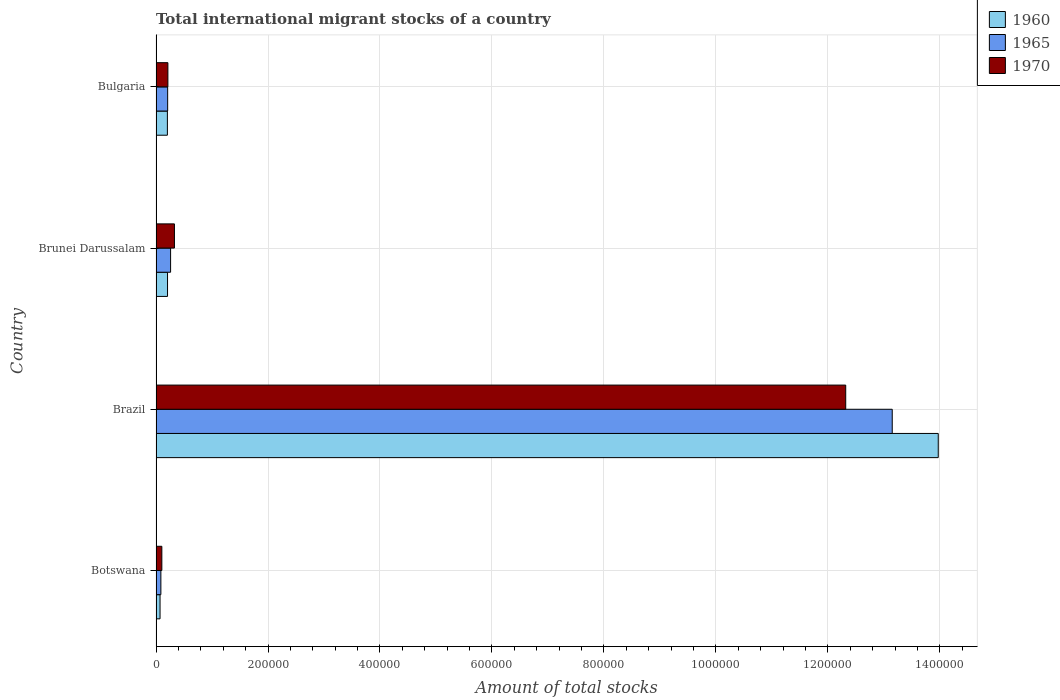How many different coloured bars are there?
Provide a short and direct response. 3. Are the number of bars on each tick of the Y-axis equal?
Provide a succinct answer. Yes. How many bars are there on the 1st tick from the top?
Ensure brevity in your answer.  3. How many bars are there on the 4th tick from the bottom?
Your answer should be very brief. 3. In how many cases, is the number of bars for a given country not equal to the number of legend labels?
Your response must be concise. 0. What is the amount of total stocks in in 1960 in Brazil?
Your response must be concise. 1.40e+06. Across all countries, what is the maximum amount of total stocks in in 1960?
Make the answer very short. 1.40e+06. Across all countries, what is the minimum amount of total stocks in in 1960?
Provide a short and direct response. 7199. In which country was the amount of total stocks in in 1965 minimum?
Your answer should be compact. Botswana. What is the total amount of total stocks in in 1965 in the graph?
Provide a succinct answer. 1.37e+06. What is the difference between the amount of total stocks in in 1965 in Brazil and that in Brunei Darussalam?
Provide a succinct answer. 1.29e+06. What is the difference between the amount of total stocks in in 1960 in Brunei Darussalam and the amount of total stocks in in 1970 in Botswana?
Your answer should be compact. 1.02e+04. What is the average amount of total stocks in in 1970 per country?
Provide a short and direct response. 3.24e+05. What is the difference between the amount of total stocks in in 1970 and amount of total stocks in in 1960 in Brazil?
Offer a very short reply. -1.65e+05. In how many countries, is the amount of total stocks in in 1970 greater than 200000 ?
Offer a very short reply. 1. What is the ratio of the amount of total stocks in in 1970 in Botswana to that in Brazil?
Provide a succinct answer. 0.01. Is the amount of total stocks in in 1960 in Botswana less than that in Brunei Darussalam?
Provide a succinct answer. Yes. What is the difference between the highest and the second highest amount of total stocks in in 1970?
Make the answer very short. 1.20e+06. What is the difference between the highest and the lowest amount of total stocks in in 1970?
Provide a succinct answer. 1.22e+06. In how many countries, is the amount of total stocks in in 1965 greater than the average amount of total stocks in in 1965 taken over all countries?
Provide a succinct answer. 1. How many bars are there?
Give a very brief answer. 12. How many countries are there in the graph?
Provide a succinct answer. 4. What is the difference between two consecutive major ticks on the X-axis?
Ensure brevity in your answer.  2.00e+05. Where does the legend appear in the graph?
Provide a short and direct response. Top right. How many legend labels are there?
Your response must be concise. 3. What is the title of the graph?
Keep it short and to the point. Total international migrant stocks of a country. What is the label or title of the X-axis?
Your answer should be very brief. Amount of total stocks. What is the label or title of the Y-axis?
Provide a short and direct response. Country. What is the Amount of total stocks in 1960 in Botswana?
Offer a very short reply. 7199. What is the Amount of total stocks of 1965 in Botswana?
Provide a succinct answer. 8655. What is the Amount of total stocks of 1970 in Botswana?
Provide a short and direct response. 1.04e+04. What is the Amount of total stocks of 1960 in Brazil?
Give a very brief answer. 1.40e+06. What is the Amount of total stocks of 1965 in Brazil?
Offer a very short reply. 1.31e+06. What is the Amount of total stocks of 1970 in Brazil?
Make the answer very short. 1.23e+06. What is the Amount of total stocks in 1960 in Brunei Darussalam?
Offer a terse response. 2.06e+04. What is the Amount of total stocks in 1965 in Brunei Darussalam?
Give a very brief answer. 2.60e+04. What is the Amount of total stocks of 1970 in Brunei Darussalam?
Provide a succinct answer. 3.29e+04. What is the Amount of total stocks of 1960 in Bulgaria?
Provide a succinct answer. 2.03e+04. What is the Amount of total stocks of 1965 in Bulgaria?
Provide a succinct answer. 2.08e+04. What is the Amount of total stocks of 1970 in Bulgaria?
Provide a succinct answer. 2.12e+04. Across all countries, what is the maximum Amount of total stocks in 1960?
Make the answer very short. 1.40e+06. Across all countries, what is the maximum Amount of total stocks in 1965?
Make the answer very short. 1.31e+06. Across all countries, what is the maximum Amount of total stocks of 1970?
Make the answer very short. 1.23e+06. Across all countries, what is the minimum Amount of total stocks in 1960?
Make the answer very short. 7199. Across all countries, what is the minimum Amount of total stocks of 1965?
Your answer should be very brief. 8655. Across all countries, what is the minimum Amount of total stocks of 1970?
Your answer should be very brief. 1.04e+04. What is the total Amount of total stocks in 1960 in the graph?
Offer a terse response. 1.45e+06. What is the total Amount of total stocks in 1965 in the graph?
Keep it short and to the point. 1.37e+06. What is the total Amount of total stocks in 1970 in the graph?
Your response must be concise. 1.30e+06. What is the difference between the Amount of total stocks in 1960 in Botswana and that in Brazil?
Your answer should be compact. -1.39e+06. What is the difference between the Amount of total stocks in 1965 in Botswana and that in Brazil?
Keep it short and to the point. -1.31e+06. What is the difference between the Amount of total stocks of 1970 in Botswana and that in Brazil?
Offer a terse response. -1.22e+06. What is the difference between the Amount of total stocks in 1960 in Botswana and that in Brunei Darussalam?
Offer a terse response. -1.34e+04. What is the difference between the Amount of total stocks of 1965 in Botswana and that in Brunei Darussalam?
Your response must be concise. -1.74e+04. What is the difference between the Amount of total stocks in 1970 in Botswana and that in Brunei Darussalam?
Provide a short and direct response. -2.25e+04. What is the difference between the Amount of total stocks of 1960 in Botswana and that in Bulgaria?
Offer a terse response. -1.31e+04. What is the difference between the Amount of total stocks in 1965 in Botswana and that in Bulgaria?
Provide a short and direct response. -1.21e+04. What is the difference between the Amount of total stocks in 1970 in Botswana and that in Bulgaria?
Ensure brevity in your answer.  -1.08e+04. What is the difference between the Amount of total stocks of 1960 in Brazil and that in Brunei Darussalam?
Your response must be concise. 1.38e+06. What is the difference between the Amount of total stocks of 1965 in Brazil and that in Brunei Darussalam?
Provide a short and direct response. 1.29e+06. What is the difference between the Amount of total stocks of 1970 in Brazil and that in Brunei Darussalam?
Provide a short and direct response. 1.20e+06. What is the difference between the Amount of total stocks in 1960 in Brazil and that in Bulgaria?
Your response must be concise. 1.38e+06. What is the difference between the Amount of total stocks of 1965 in Brazil and that in Bulgaria?
Provide a succinct answer. 1.29e+06. What is the difference between the Amount of total stocks in 1970 in Brazil and that in Bulgaria?
Provide a short and direct response. 1.21e+06. What is the difference between the Amount of total stocks in 1960 in Brunei Darussalam and that in Bulgaria?
Keep it short and to the point. 267. What is the difference between the Amount of total stocks of 1965 in Brunei Darussalam and that in Bulgaria?
Keep it short and to the point. 5255. What is the difference between the Amount of total stocks of 1970 in Brunei Darussalam and that in Bulgaria?
Ensure brevity in your answer.  1.17e+04. What is the difference between the Amount of total stocks in 1960 in Botswana and the Amount of total stocks in 1965 in Brazil?
Your answer should be very brief. -1.31e+06. What is the difference between the Amount of total stocks of 1960 in Botswana and the Amount of total stocks of 1970 in Brazil?
Offer a very short reply. -1.22e+06. What is the difference between the Amount of total stocks of 1965 in Botswana and the Amount of total stocks of 1970 in Brazil?
Your response must be concise. -1.22e+06. What is the difference between the Amount of total stocks of 1960 in Botswana and the Amount of total stocks of 1965 in Brunei Darussalam?
Offer a very short reply. -1.88e+04. What is the difference between the Amount of total stocks of 1960 in Botswana and the Amount of total stocks of 1970 in Brunei Darussalam?
Your answer should be compact. -2.57e+04. What is the difference between the Amount of total stocks in 1965 in Botswana and the Amount of total stocks in 1970 in Brunei Darussalam?
Provide a succinct answer. -2.42e+04. What is the difference between the Amount of total stocks in 1960 in Botswana and the Amount of total stocks in 1965 in Bulgaria?
Your answer should be very brief. -1.36e+04. What is the difference between the Amount of total stocks of 1960 in Botswana and the Amount of total stocks of 1970 in Bulgaria?
Give a very brief answer. -1.40e+04. What is the difference between the Amount of total stocks of 1965 in Botswana and the Amount of total stocks of 1970 in Bulgaria?
Give a very brief answer. -1.25e+04. What is the difference between the Amount of total stocks of 1960 in Brazil and the Amount of total stocks of 1965 in Brunei Darussalam?
Provide a short and direct response. 1.37e+06. What is the difference between the Amount of total stocks in 1960 in Brazil and the Amount of total stocks in 1970 in Brunei Darussalam?
Provide a succinct answer. 1.36e+06. What is the difference between the Amount of total stocks in 1965 in Brazil and the Amount of total stocks in 1970 in Brunei Darussalam?
Give a very brief answer. 1.28e+06. What is the difference between the Amount of total stocks in 1960 in Brazil and the Amount of total stocks in 1965 in Bulgaria?
Offer a very short reply. 1.38e+06. What is the difference between the Amount of total stocks of 1960 in Brazil and the Amount of total stocks of 1970 in Bulgaria?
Your answer should be very brief. 1.38e+06. What is the difference between the Amount of total stocks of 1965 in Brazil and the Amount of total stocks of 1970 in Bulgaria?
Provide a short and direct response. 1.29e+06. What is the difference between the Amount of total stocks in 1960 in Brunei Darussalam and the Amount of total stocks in 1965 in Bulgaria?
Make the answer very short. -221. What is the difference between the Amount of total stocks of 1960 in Brunei Darussalam and the Amount of total stocks of 1970 in Bulgaria?
Ensure brevity in your answer.  -627. What is the difference between the Amount of total stocks of 1965 in Brunei Darussalam and the Amount of total stocks of 1970 in Bulgaria?
Offer a very short reply. 4849. What is the average Amount of total stocks in 1960 per country?
Ensure brevity in your answer.  3.61e+05. What is the average Amount of total stocks of 1965 per country?
Offer a very short reply. 3.43e+05. What is the average Amount of total stocks of 1970 per country?
Your response must be concise. 3.24e+05. What is the difference between the Amount of total stocks in 1960 and Amount of total stocks in 1965 in Botswana?
Your response must be concise. -1456. What is the difference between the Amount of total stocks of 1960 and Amount of total stocks of 1970 in Botswana?
Your answer should be very brief. -3205. What is the difference between the Amount of total stocks in 1965 and Amount of total stocks in 1970 in Botswana?
Give a very brief answer. -1749. What is the difference between the Amount of total stocks of 1960 and Amount of total stocks of 1965 in Brazil?
Provide a short and direct response. 8.22e+04. What is the difference between the Amount of total stocks of 1960 and Amount of total stocks of 1970 in Brazil?
Ensure brevity in your answer.  1.65e+05. What is the difference between the Amount of total stocks in 1965 and Amount of total stocks in 1970 in Brazil?
Provide a succinct answer. 8.31e+04. What is the difference between the Amount of total stocks of 1960 and Amount of total stocks of 1965 in Brunei Darussalam?
Ensure brevity in your answer.  -5476. What is the difference between the Amount of total stocks of 1960 and Amount of total stocks of 1970 in Brunei Darussalam?
Offer a very short reply. -1.23e+04. What is the difference between the Amount of total stocks in 1965 and Amount of total stocks in 1970 in Brunei Darussalam?
Keep it short and to the point. -6865. What is the difference between the Amount of total stocks in 1960 and Amount of total stocks in 1965 in Bulgaria?
Provide a succinct answer. -488. What is the difference between the Amount of total stocks in 1960 and Amount of total stocks in 1970 in Bulgaria?
Provide a succinct answer. -894. What is the difference between the Amount of total stocks of 1965 and Amount of total stocks of 1970 in Bulgaria?
Your response must be concise. -406. What is the ratio of the Amount of total stocks of 1960 in Botswana to that in Brazil?
Ensure brevity in your answer.  0.01. What is the ratio of the Amount of total stocks of 1965 in Botswana to that in Brazil?
Offer a terse response. 0.01. What is the ratio of the Amount of total stocks of 1970 in Botswana to that in Brazil?
Make the answer very short. 0.01. What is the ratio of the Amount of total stocks in 1960 in Botswana to that in Brunei Darussalam?
Your response must be concise. 0.35. What is the ratio of the Amount of total stocks of 1965 in Botswana to that in Brunei Darussalam?
Give a very brief answer. 0.33. What is the ratio of the Amount of total stocks in 1970 in Botswana to that in Brunei Darussalam?
Your response must be concise. 0.32. What is the ratio of the Amount of total stocks of 1960 in Botswana to that in Bulgaria?
Provide a succinct answer. 0.35. What is the ratio of the Amount of total stocks of 1965 in Botswana to that in Bulgaria?
Provide a short and direct response. 0.42. What is the ratio of the Amount of total stocks in 1970 in Botswana to that in Bulgaria?
Offer a terse response. 0.49. What is the ratio of the Amount of total stocks of 1960 in Brazil to that in Brunei Darussalam?
Ensure brevity in your answer.  67.95. What is the ratio of the Amount of total stocks of 1965 in Brazil to that in Brunei Darussalam?
Your response must be concise. 50.5. What is the ratio of the Amount of total stocks of 1970 in Brazil to that in Brunei Darussalam?
Provide a succinct answer. 37.44. What is the ratio of the Amount of total stocks of 1960 in Brazil to that in Bulgaria?
Your answer should be compact. 68.84. What is the ratio of the Amount of total stocks of 1965 in Brazil to that in Bulgaria?
Your answer should be very brief. 63.27. What is the ratio of the Amount of total stocks in 1970 in Brazil to that in Bulgaria?
Ensure brevity in your answer.  58.14. What is the ratio of the Amount of total stocks of 1960 in Brunei Darussalam to that in Bulgaria?
Your response must be concise. 1.01. What is the ratio of the Amount of total stocks of 1965 in Brunei Darussalam to that in Bulgaria?
Ensure brevity in your answer.  1.25. What is the ratio of the Amount of total stocks in 1970 in Brunei Darussalam to that in Bulgaria?
Give a very brief answer. 1.55. What is the difference between the highest and the second highest Amount of total stocks of 1960?
Provide a short and direct response. 1.38e+06. What is the difference between the highest and the second highest Amount of total stocks in 1965?
Provide a short and direct response. 1.29e+06. What is the difference between the highest and the second highest Amount of total stocks of 1970?
Give a very brief answer. 1.20e+06. What is the difference between the highest and the lowest Amount of total stocks in 1960?
Keep it short and to the point. 1.39e+06. What is the difference between the highest and the lowest Amount of total stocks in 1965?
Your response must be concise. 1.31e+06. What is the difference between the highest and the lowest Amount of total stocks in 1970?
Provide a short and direct response. 1.22e+06. 